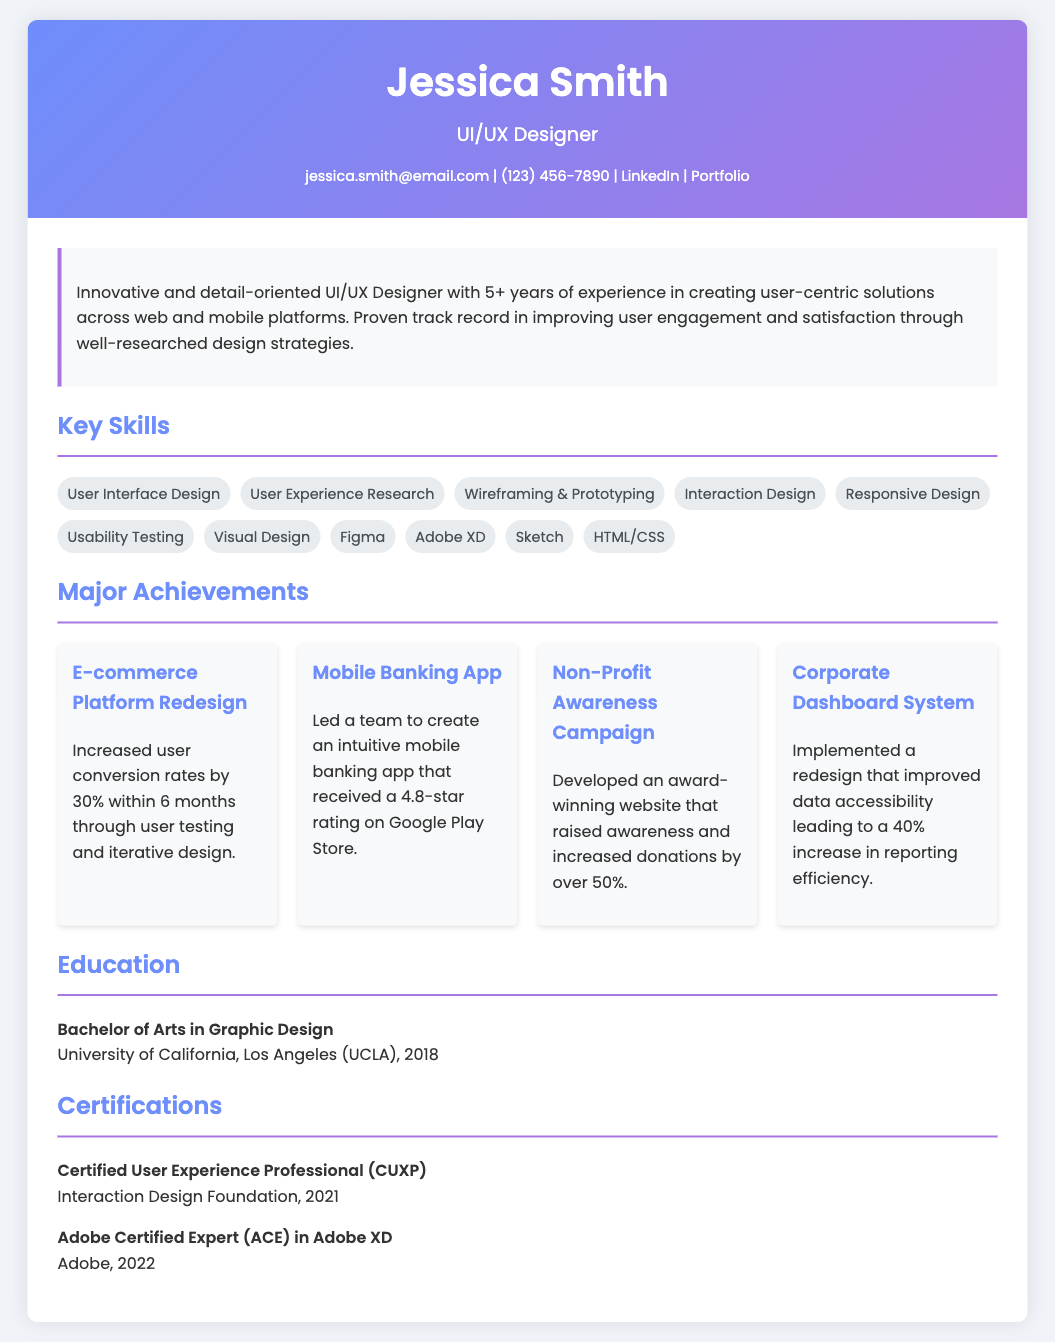What is the name of the designer? The name of the designer is stated at the top of the document.
Answer: Jessica Smith How many years of experience does the designer have? The designer's experience is mentioned in the summary of the CV.
Answer: 5+ What degree did the designer earn? The designer's education section lists the degree earned.
Answer: Bachelor of Arts in Graphic Design Which tool is mentioned as a certification? The certifications section lists specific certifications earned.
Answer: Adobe XD What was achieved through the e-commerce platform redesign? The specific achievement related to the e-commerce platform redesign is stated in the achievements section.
Answer: Increased user conversion rates by 30% How many certifications does the designer have? The certifications section enumerates the certifications listed.
Answer: 2 What is the rating of the mobile banking app? The achievement related to the mobile banking app includes its rating on the app store.
Answer: 4.8-star rating What university did the designer attend? The education section specifies the university attended by the designer.
Answer: University of California, Los Angeles What design tool is listed first in the skills? The skills section lists the tools and skills the designer has mastered.
Answer: User Interface Design 